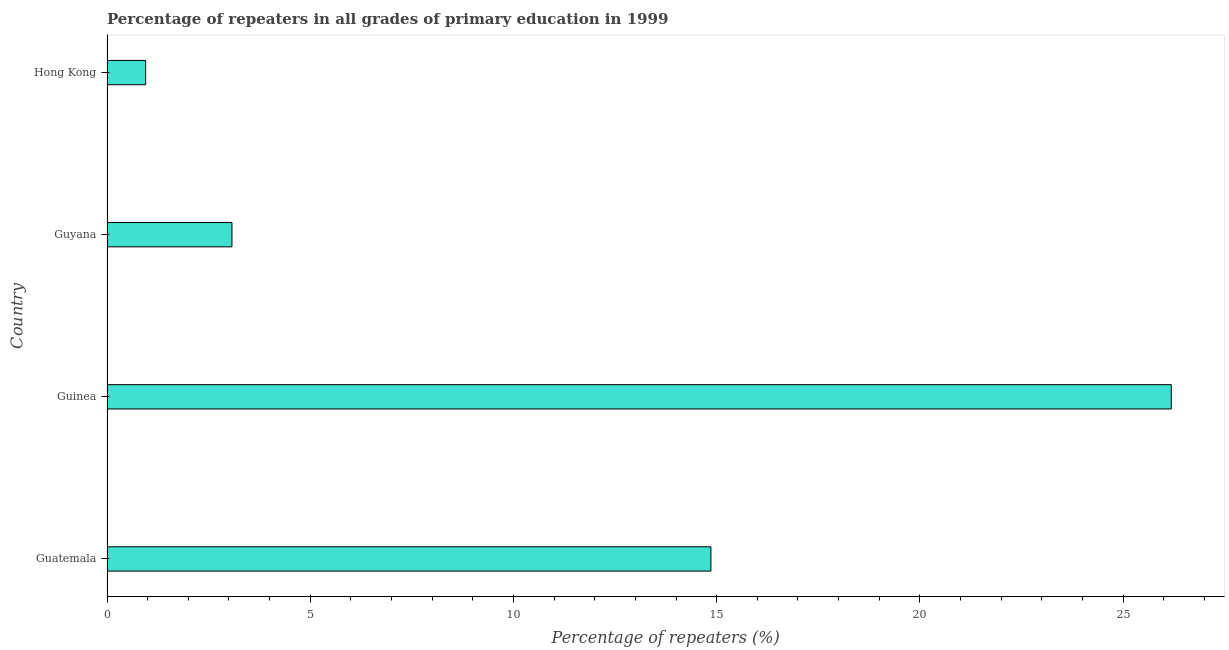Does the graph contain grids?
Offer a very short reply. No. What is the title of the graph?
Provide a succinct answer. Percentage of repeaters in all grades of primary education in 1999. What is the label or title of the X-axis?
Ensure brevity in your answer.  Percentage of repeaters (%). What is the percentage of repeaters in primary education in Guinea?
Keep it short and to the point. 26.19. Across all countries, what is the maximum percentage of repeaters in primary education?
Provide a succinct answer. 26.19. Across all countries, what is the minimum percentage of repeaters in primary education?
Offer a terse response. 0.95. In which country was the percentage of repeaters in primary education maximum?
Offer a terse response. Guinea. In which country was the percentage of repeaters in primary education minimum?
Your answer should be compact. Hong Kong. What is the sum of the percentage of repeaters in primary education?
Make the answer very short. 45.07. What is the difference between the percentage of repeaters in primary education in Guatemala and Guyana?
Your response must be concise. 11.79. What is the average percentage of repeaters in primary education per country?
Your answer should be compact. 11.27. What is the median percentage of repeaters in primary education?
Ensure brevity in your answer.  8.97. In how many countries, is the percentage of repeaters in primary education greater than 4 %?
Provide a succinct answer. 2. What is the ratio of the percentage of repeaters in primary education in Guinea to that in Guyana?
Offer a terse response. 8.52. Is the percentage of repeaters in primary education in Guatemala less than that in Guyana?
Give a very brief answer. No. What is the difference between the highest and the second highest percentage of repeaters in primary education?
Offer a terse response. 11.33. What is the difference between the highest and the lowest percentage of repeaters in primary education?
Provide a short and direct response. 25.24. In how many countries, is the percentage of repeaters in primary education greater than the average percentage of repeaters in primary education taken over all countries?
Your response must be concise. 2. How many bars are there?
Give a very brief answer. 4. How many countries are there in the graph?
Provide a short and direct response. 4. Are the values on the major ticks of X-axis written in scientific E-notation?
Keep it short and to the point. No. What is the Percentage of repeaters (%) of Guatemala?
Keep it short and to the point. 14.86. What is the Percentage of repeaters (%) in Guinea?
Provide a succinct answer. 26.19. What is the Percentage of repeaters (%) of Guyana?
Your answer should be very brief. 3.07. What is the Percentage of repeaters (%) of Hong Kong?
Offer a very short reply. 0.95. What is the difference between the Percentage of repeaters (%) in Guatemala and Guinea?
Ensure brevity in your answer.  -11.33. What is the difference between the Percentage of repeaters (%) in Guatemala and Guyana?
Provide a succinct answer. 11.79. What is the difference between the Percentage of repeaters (%) in Guatemala and Hong Kong?
Provide a short and direct response. 13.91. What is the difference between the Percentage of repeaters (%) in Guinea and Guyana?
Provide a short and direct response. 23.11. What is the difference between the Percentage of repeaters (%) in Guinea and Hong Kong?
Keep it short and to the point. 25.24. What is the difference between the Percentage of repeaters (%) in Guyana and Hong Kong?
Provide a succinct answer. 2.12. What is the ratio of the Percentage of repeaters (%) in Guatemala to that in Guinea?
Make the answer very short. 0.57. What is the ratio of the Percentage of repeaters (%) in Guatemala to that in Guyana?
Provide a short and direct response. 4.83. What is the ratio of the Percentage of repeaters (%) in Guatemala to that in Hong Kong?
Ensure brevity in your answer.  15.63. What is the ratio of the Percentage of repeaters (%) in Guinea to that in Guyana?
Give a very brief answer. 8.52. What is the ratio of the Percentage of repeaters (%) in Guinea to that in Hong Kong?
Ensure brevity in your answer.  27.55. What is the ratio of the Percentage of repeaters (%) in Guyana to that in Hong Kong?
Provide a short and direct response. 3.23. 